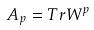<formula> <loc_0><loc_0><loc_500><loc_500>A _ { p } = T r W ^ { p }</formula> 